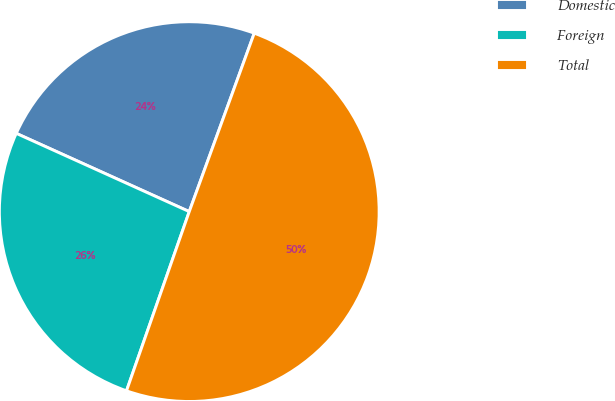Convert chart. <chart><loc_0><loc_0><loc_500><loc_500><pie_chart><fcel>Domestic<fcel>Foreign<fcel>Total<nl><fcel>23.8%<fcel>26.4%<fcel>49.8%<nl></chart> 